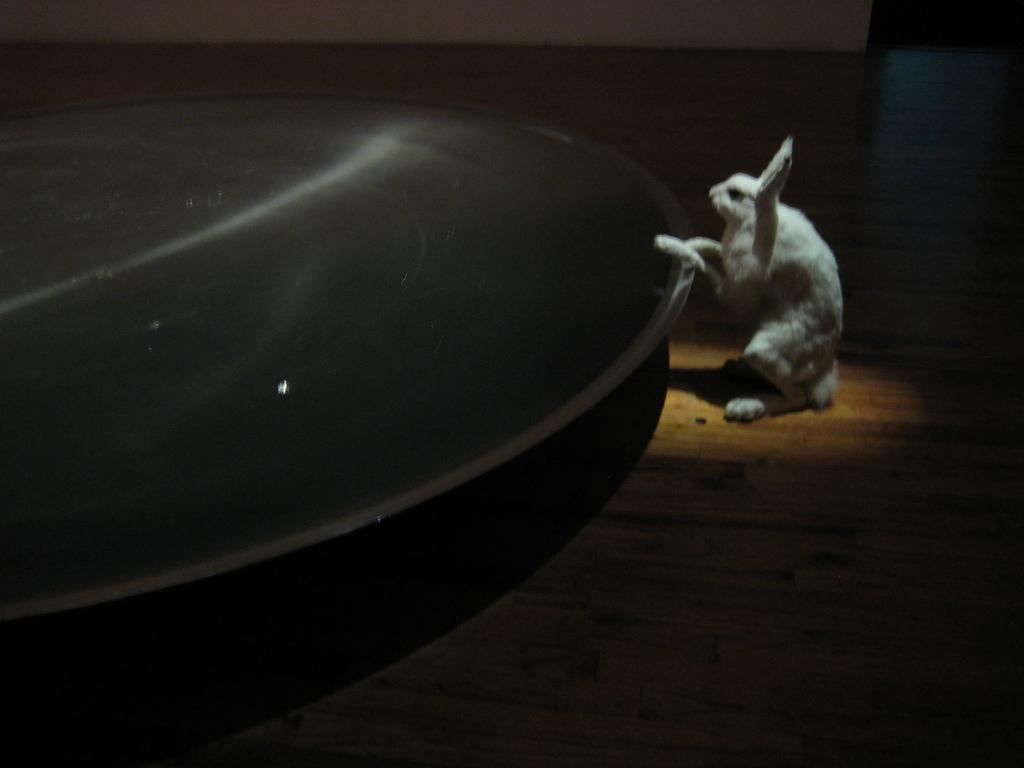What type of animal is in the image? There is a rabbit in the image. Can you describe the other object in the image? Unfortunately, there is not enough information provided to describe the other object in the image. What is the rabbit's fifth memory of the taste of carrots? There is not enough information provided to answer this question. The image only shows a rabbit and another object, without any context or additional information, it is impossible to determine the rabbit's memory or taste preferences. 